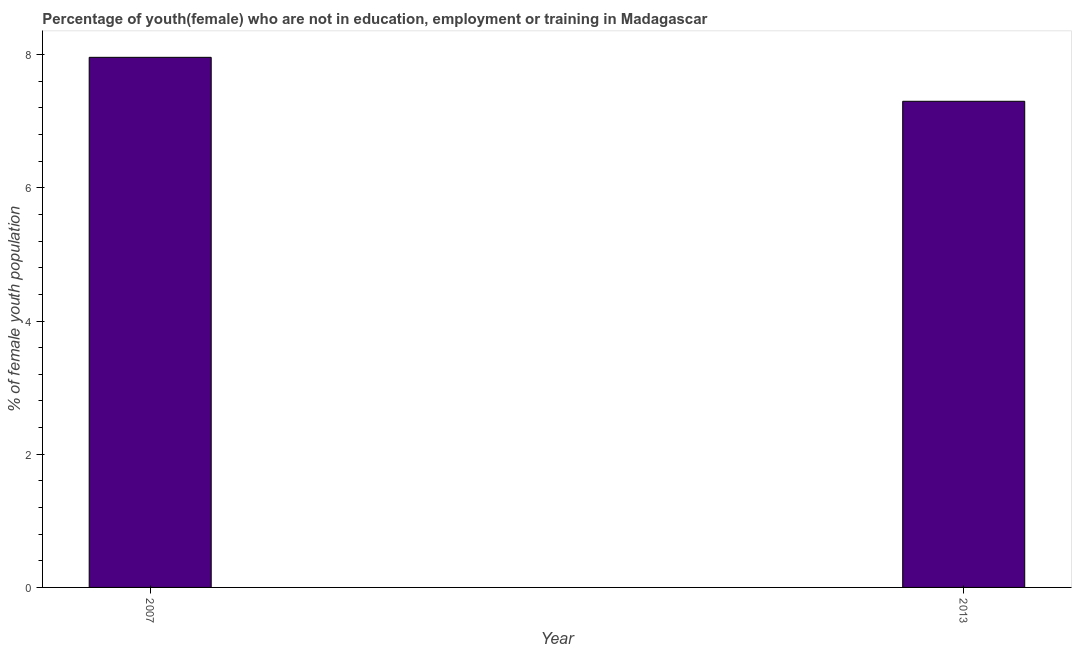Does the graph contain grids?
Give a very brief answer. No. What is the title of the graph?
Keep it short and to the point. Percentage of youth(female) who are not in education, employment or training in Madagascar. What is the label or title of the X-axis?
Your answer should be compact. Year. What is the label or title of the Y-axis?
Your response must be concise. % of female youth population. What is the unemployed female youth population in 2013?
Provide a short and direct response. 7.3. Across all years, what is the maximum unemployed female youth population?
Your response must be concise. 7.96. Across all years, what is the minimum unemployed female youth population?
Offer a terse response. 7.3. What is the sum of the unemployed female youth population?
Keep it short and to the point. 15.26. What is the difference between the unemployed female youth population in 2007 and 2013?
Make the answer very short. 0.66. What is the average unemployed female youth population per year?
Make the answer very short. 7.63. What is the median unemployed female youth population?
Make the answer very short. 7.63. Do a majority of the years between 2007 and 2013 (inclusive) have unemployed female youth population greater than 1.6 %?
Give a very brief answer. Yes. What is the ratio of the unemployed female youth population in 2007 to that in 2013?
Ensure brevity in your answer.  1.09. How many bars are there?
Ensure brevity in your answer.  2. Are all the bars in the graph horizontal?
Offer a terse response. No. How many years are there in the graph?
Provide a short and direct response. 2. What is the % of female youth population in 2007?
Your answer should be compact. 7.96. What is the % of female youth population of 2013?
Offer a very short reply. 7.3. What is the difference between the % of female youth population in 2007 and 2013?
Provide a succinct answer. 0.66. What is the ratio of the % of female youth population in 2007 to that in 2013?
Provide a short and direct response. 1.09. 